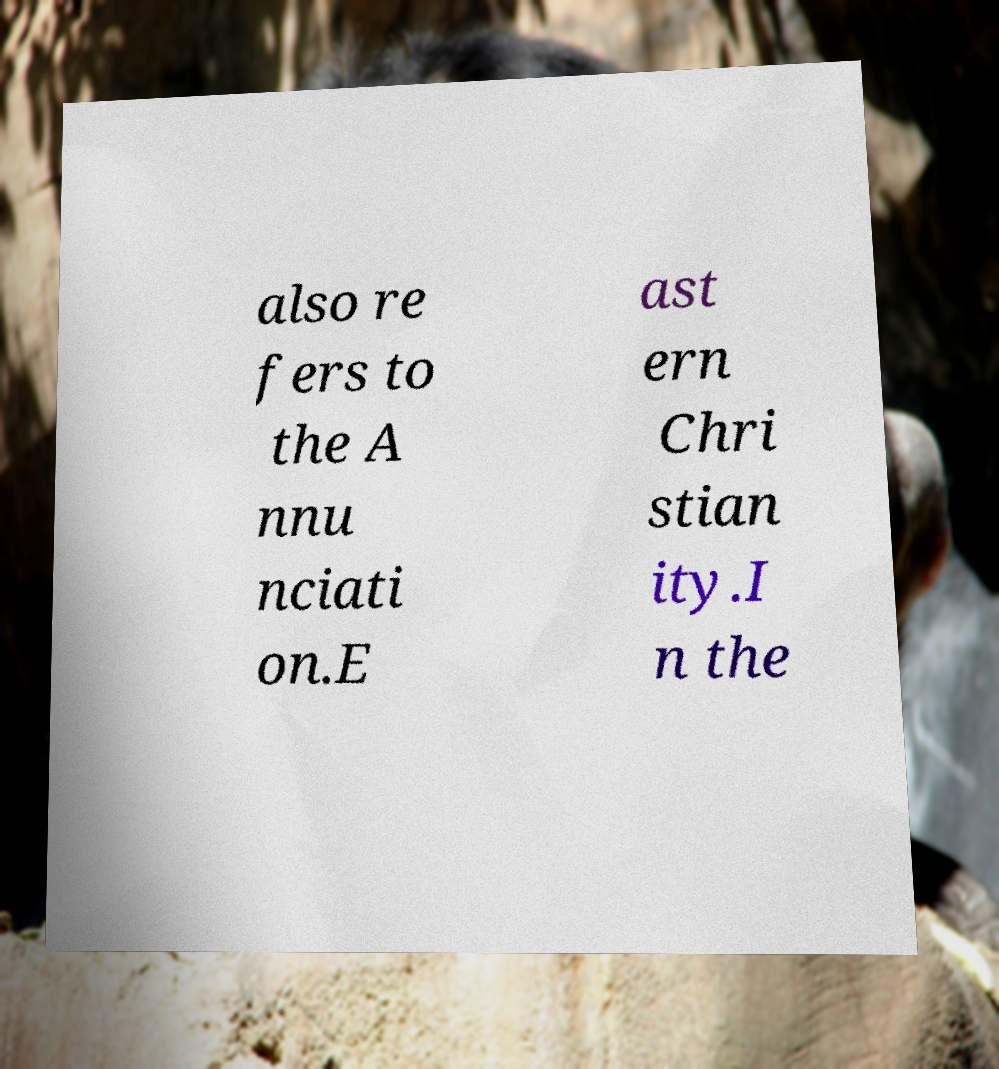Please identify and transcribe the text found in this image. also re fers to the A nnu nciati on.E ast ern Chri stian ity.I n the 